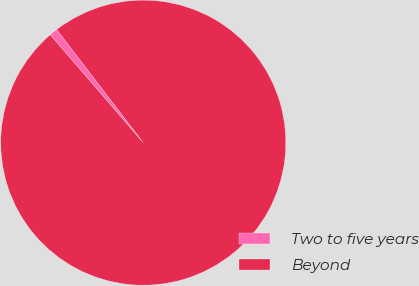Convert chart. <chart><loc_0><loc_0><loc_500><loc_500><pie_chart><fcel>Two to five years<fcel>Beyond<nl><fcel>0.92%<fcel>99.08%<nl></chart> 